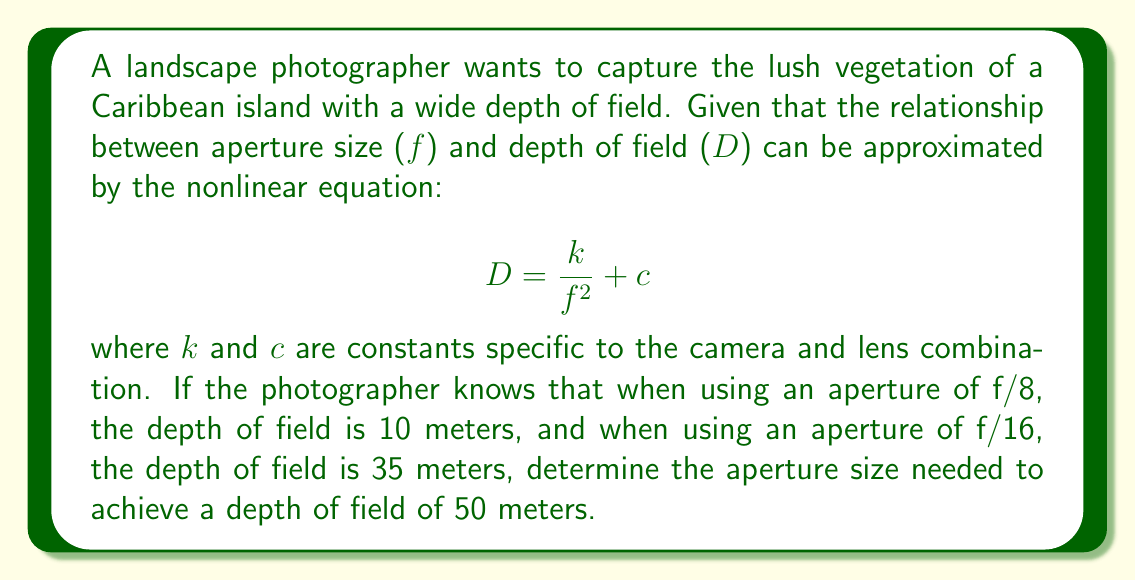Can you answer this question? Let's approach this step-by-step:

1) We have two known points:
   When $f = 8$, $D = 10$
   When $f = 16$, $D = 35$

2) Let's substitute these into our equation:
   $10 = \frac{k}{8^2} + c$
   $35 = \frac{k}{16^2} + c$

3) Simplify:
   $10 = \frac{k}{64} + c$
   $35 = \frac{k}{256} + c$

4) Subtract the first equation from the second:
   $25 = \frac{k}{256} - \frac{k}{64}$

5) Find a common denominator:
   $25 = \frac{k}{256} - \frac{4k}{256} = \frac{-3k}{256}$

6) Solve for $k$:
   $k = -\frac{25 * 256}{3} = -2133.33$

7) Substitute this back into one of our original equations to find $c$:
   $10 = \frac{-2133.33}{64} + c$
   $10 = -33.33 + c$
   $c = 43.33$

8) Now we have our complete equation:
   $$ D = \frac{-2133.33}{f^2} + 43.33 $$

9) To find the aperture for a depth of field of 50 meters, substitute $D = 50$:
   $50 = \frac{-2133.33}{f^2} + 43.33$

10) Solve for $f$:
    $6.67 = \frac{-2133.33}{f^2}$
    $f^2 = \frac{-2133.33}{6.67} = -320$
    $f = \sqrt{320} \approx 17.89$

Therefore, the photographer needs to use an aperture of approximately f/18 to achieve a depth of field of 50 meters.
Answer: f/18 